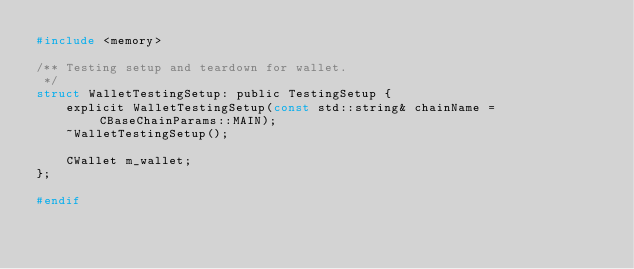<code> <loc_0><loc_0><loc_500><loc_500><_C_>#include <memory>

/** Testing setup and teardown for wallet.
 */
struct WalletTestingSetup: public TestingSetup {
    explicit WalletTestingSetup(const std::string& chainName = CBaseChainParams::MAIN);
    ~WalletTestingSetup();

    CWallet m_wallet;
};

#endif

</code> 